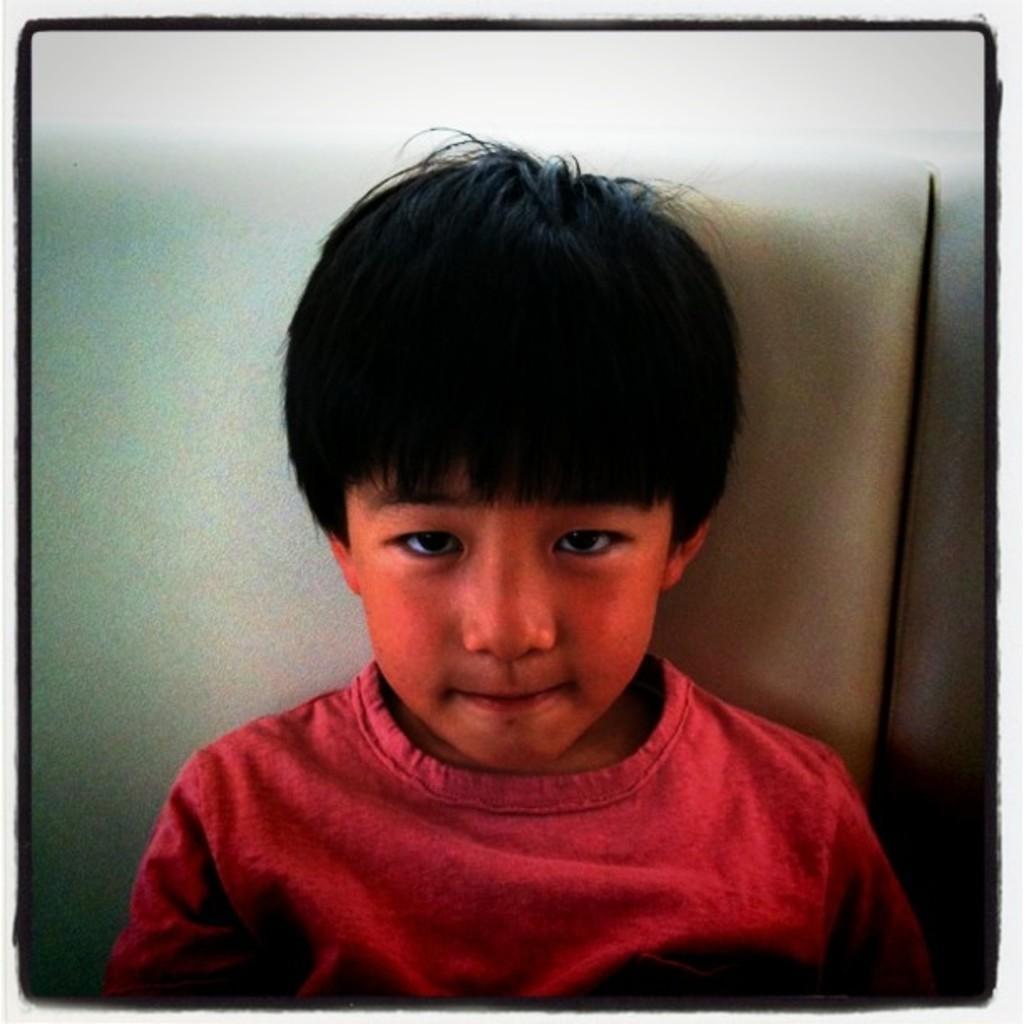Please provide a concise description of this image. In this image I can see a child wearing red colored t shirt is sitting on a seat which is cream and white in color and I can see the white colored background. 